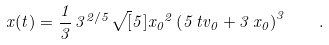<formula> <loc_0><loc_0><loc_500><loc_500>x ( t ) = \frac { 1 } { 3 } \, { 3 } ^ { 2 / 5 } \sqrt { [ } 5 ] { { x _ { 0 } } ^ { 2 } \left ( 5 \, t v _ { 0 } + 3 \, x _ { 0 } \right ) ^ { 3 } } \quad .</formula> 